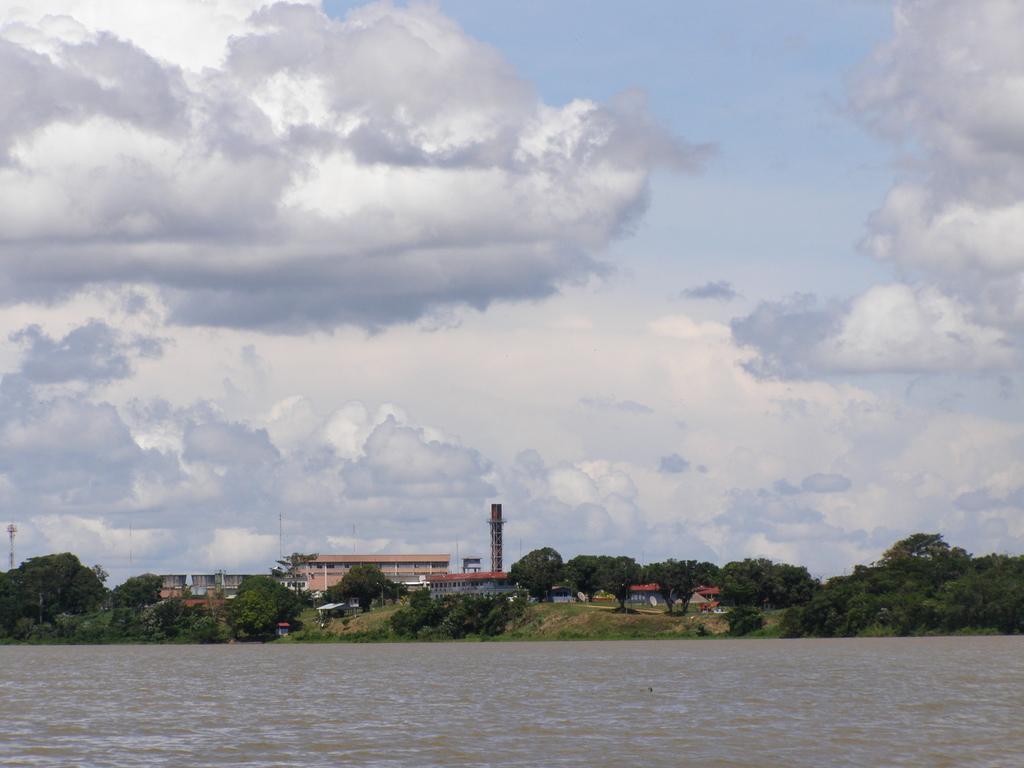How would you summarize this image in a sentence or two? In this image there is a river, trees, buildings and the sky. 